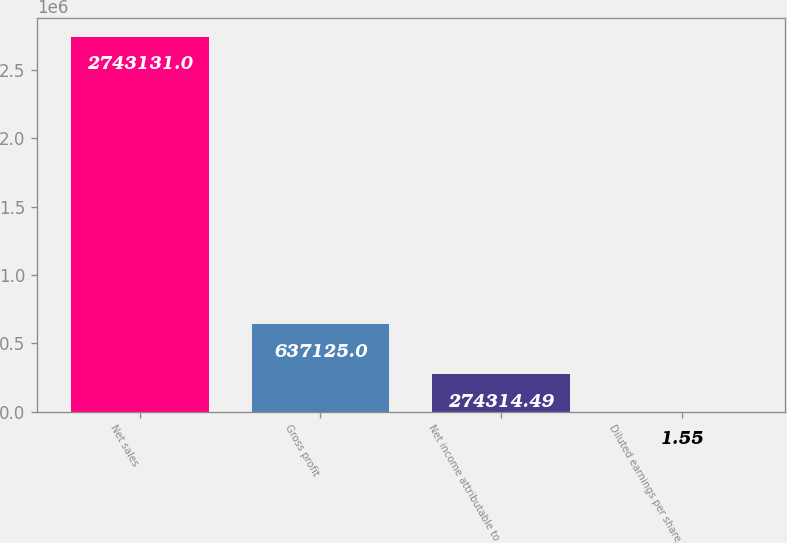Convert chart. <chart><loc_0><loc_0><loc_500><loc_500><bar_chart><fcel>Net sales<fcel>Gross profit<fcel>Net income attributable to<fcel>Diluted earnings per share<nl><fcel>2.74313e+06<fcel>637125<fcel>274314<fcel>1.55<nl></chart> 